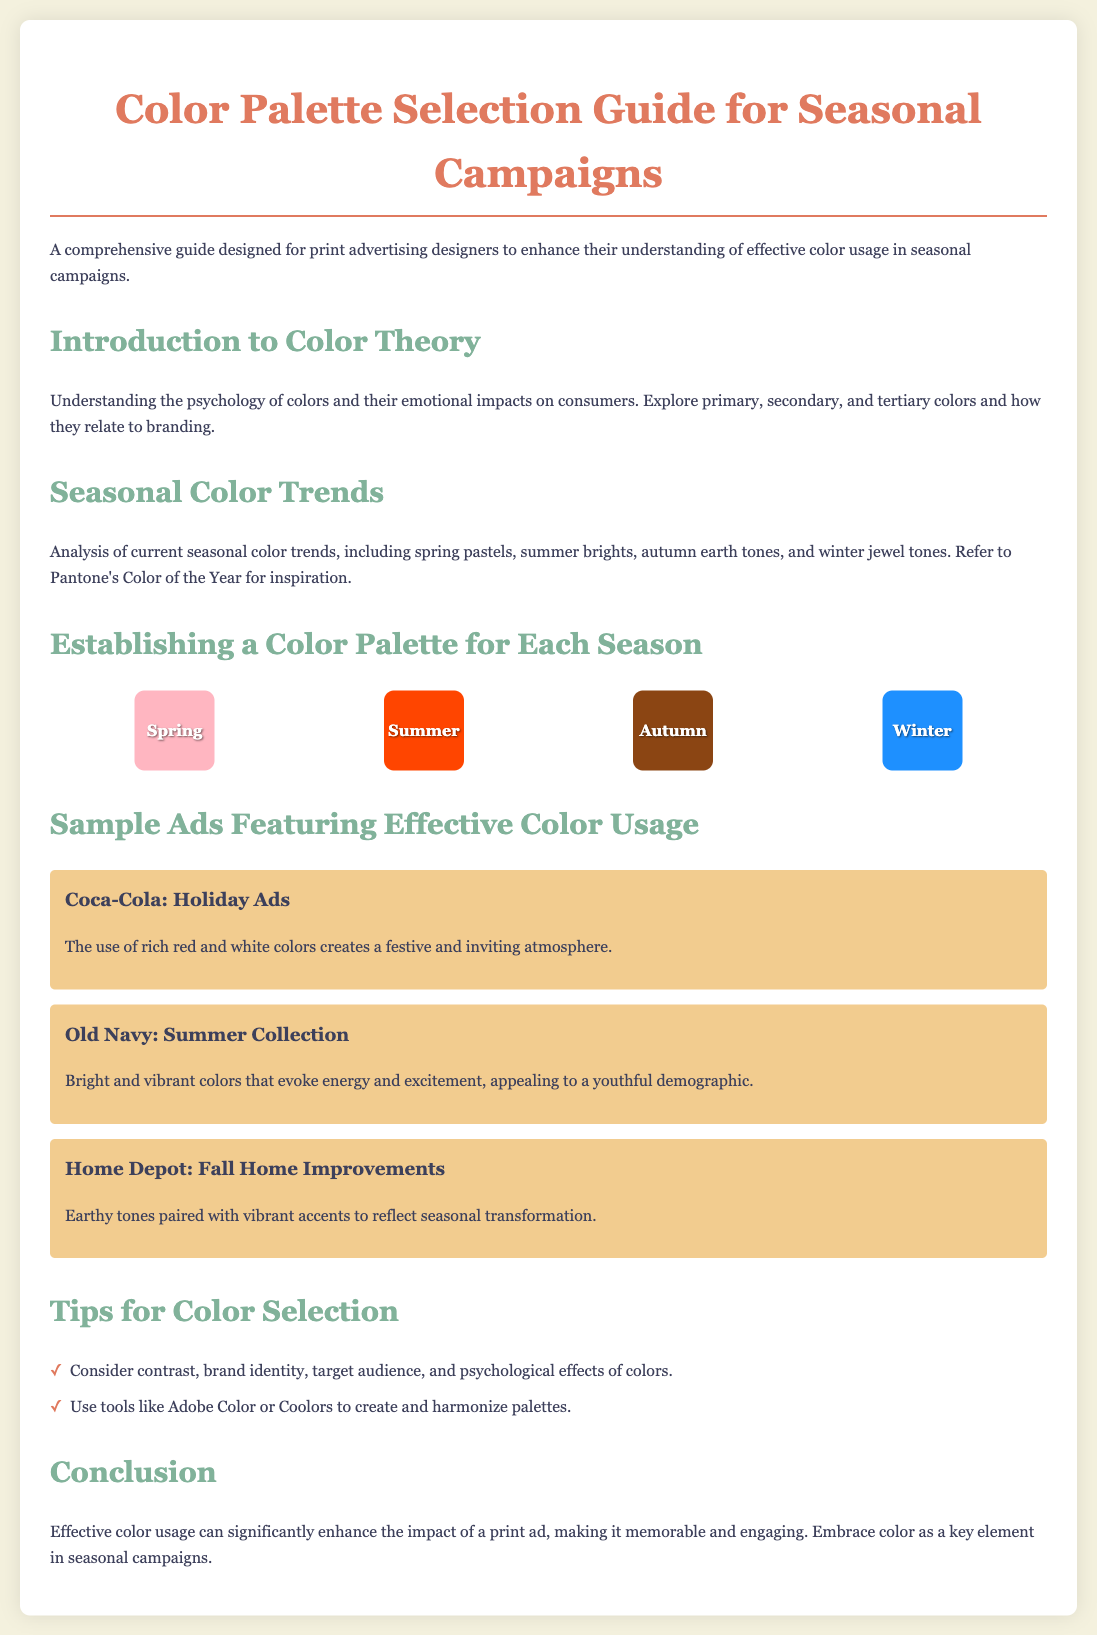What is the title of the document? The title is prominently displayed at the top of the document as a main heading.
Answer: Color Palette Selection Guide for Seasonal Campaigns What colors are associated with Spring? The colors associated with Spring are shown in the seasonal color palette section.
Answer: #FFB6C1 Which company is mentioned in the holiday ads example? The company is clearly stated in the example of effective color usage.
Answer: Coca-Cola What color is referenced for Winter campaigns? The color for Winter is listed in the seasonal color palette section.
Answer: #1E90FF What is the purpose of the document? The purpose is described in the introductory paragraph.
Answer: Enhance understanding of effective color usage What are the seasonal color trends mentioned? The document provides a brief analysis of various seasonal color trends.
Answer: Spring pastels, summer brights, autumn earth tones, winter jewel tones Name a tool suggested for creating color palettes. The document highlights tools that can assist with color palette creation.
Answer: Adobe Color What emotional impacts does color psychology explore? The document mentions various emotional impacts related to color usage.
Answer: Consumers Which brand campaign featured earthy tones? The specific brand is mentioned along with the example of effective color usage.
Answer: Home Depot How many examples of ads showcasing effective color usage are provided? The document lists a few specific ads as examples.
Answer: Three 